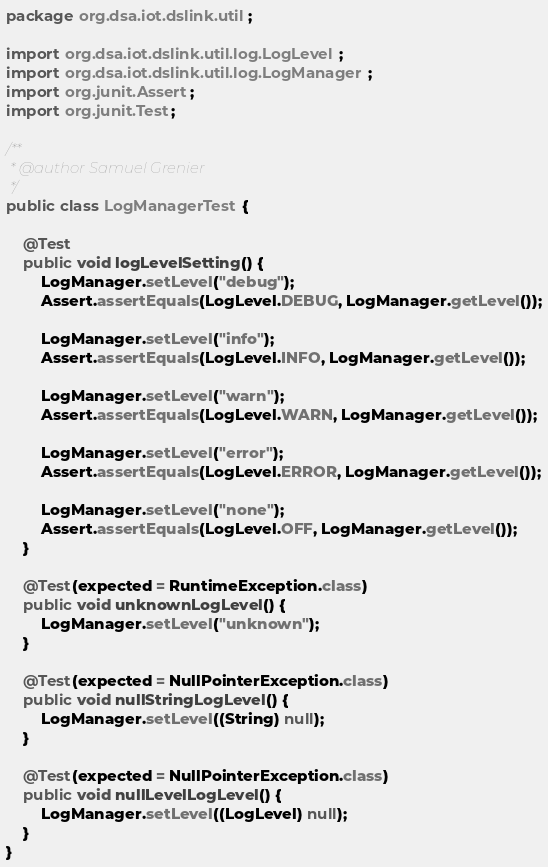Convert code to text. <code><loc_0><loc_0><loc_500><loc_500><_Java_>package org.dsa.iot.dslink.util;

import org.dsa.iot.dslink.util.log.LogLevel;
import org.dsa.iot.dslink.util.log.LogManager;
import org.junit.Assert;
import org.junit.Test;

/**
 * @author Samuel Grenier
 */
public class LogManagerTest {

    @Test
    public void logLevelSetting() {
        LogManager.setLevel("debug");
        Assert.assertEquals(LogLevel.DEBUG, LogManager.getLevel());

        LogManager.setLevel("info");
        Assert.assertEquals(LogLevel.INFO, LogManager.getLevel());

        LogManager.setLevel("warn");
        Assert.assertEquals(LogLevel.WARN, LogManager.getLevel());

        LogManager.setLevel("error");
        Assert.assertEquals(LogLevel.ERROR, LogManager.getLevel());

        LogManager.setLevel("none");
        Assert.assertEquals(LogLevel.OFF, LogManager.getLevel());
    }

    @Test(expected = RuntimeException.class)
    public void unknownLogLevel() {
        LogManager.setLevel("unknown");
    }

    @Test(expected = NullPointerException.class)
    public void nullStringLogLevel() {
        LogManager.setLevel((String) null);
    }

    @Test(expected = NullPointerException.class)
    public void nullLevelLogLevel() {
        LogManager.setLevel((LogLevel) null);
    }
}
</code> 